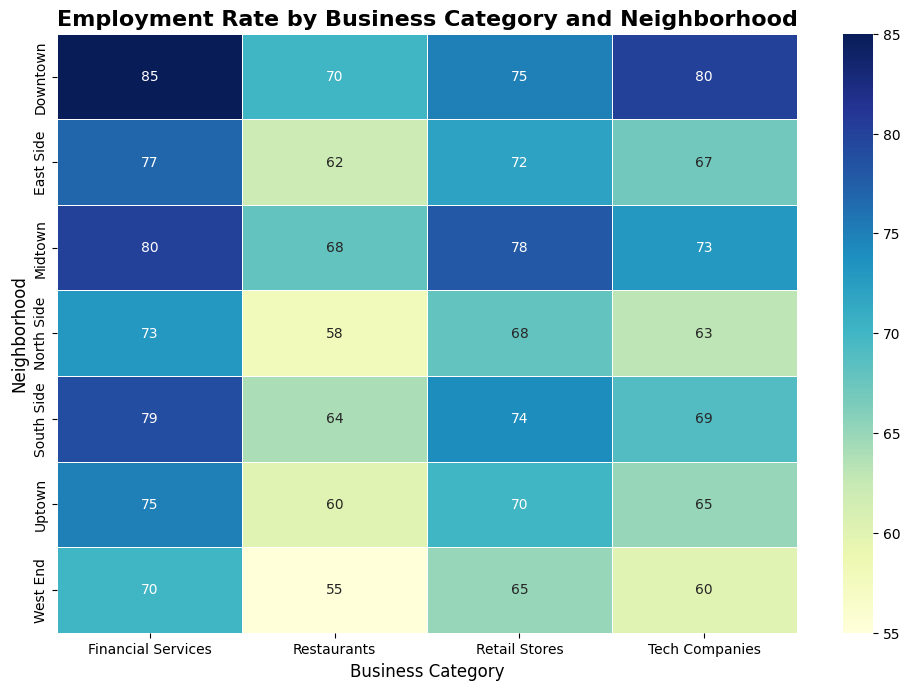Which neighborhood has the highest employment rate in Tech Companies? Look at the Tech Companies column and identify the highest number. Here, Downtown has an employment rate of 80%, which is the highest.
Answer: Downtown Compare the employment rates of Financial Services between Uptown and West End. Which is higher? Look at the Financial Services row for both Uptown and West End and compare their values. Uptown has 75%, while West End has 70%. 75% is higher.
Answer: Uptown What is the average employment rate in Restaurants across all neighborhoods? Sum the employment rates in the Restaurants column (70+60+68+55+62+58+64 = 437) and divide by the number of neighborhoods (7), which gives an average of 62.43%.
Answer: 62.43% Which neighborhood has the lowest employment rate in Retail Stores? Look at the Retail Stores column and identify the lowest number. Here, West End has the lowest employment rate of 65%.
Answer: West End How much higher is the employment rate for Financial Services in Downtown compared to the West End? Subtract the employment rate of Financial Services in West End from the rate in Downtown (85% - 70% = 15%).
Answer: 15% What is the employment rate difference between Tech Companies and Retail Stores in Midtown? Subtract the employment rate of Retail Stores from Tech Companies in Midtown (78% - 73% = 5%).
Answer: 5% Which business category has the most even distribution of employment rates across all neighborhoods? Observe the heatmap and compare the variance in shades for each business category. Financial Services seems to have the most consistently similar shades, indicating the most even distribution.
Answer: Financial Services What is the total employment rate for Tech Companies across all neighborhoods? Add up the employment rates for Tech Companies across all neighborhoods (80+65+73+60+67+63+69 = 477).
Answer: 477 In which neighborhood is the employment rate in Restaurants lower than that in Tech Companies but higher than that in Retail Stores? Compare the employment rate in Restaurants, Tech Companies, and Retail Stores across the neighborhoods. South Side fits this description with 64% in Restaurants, 69% in Tech Companies, and 74% in Retail Stores.
Answer: South Side 